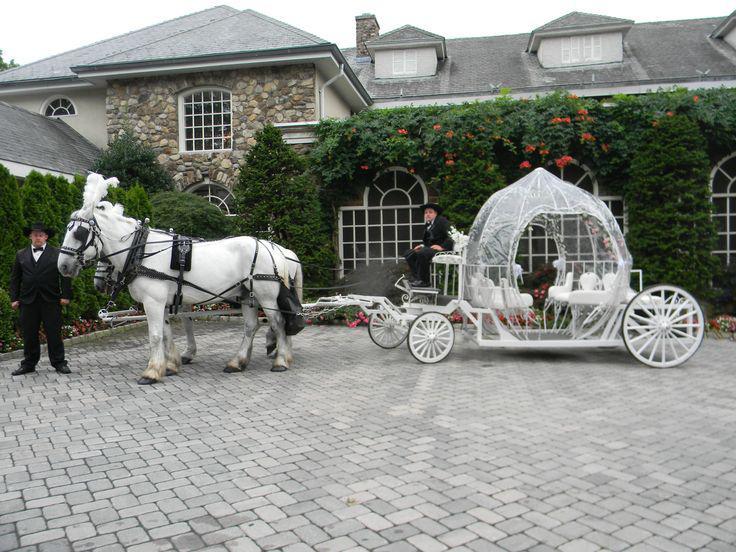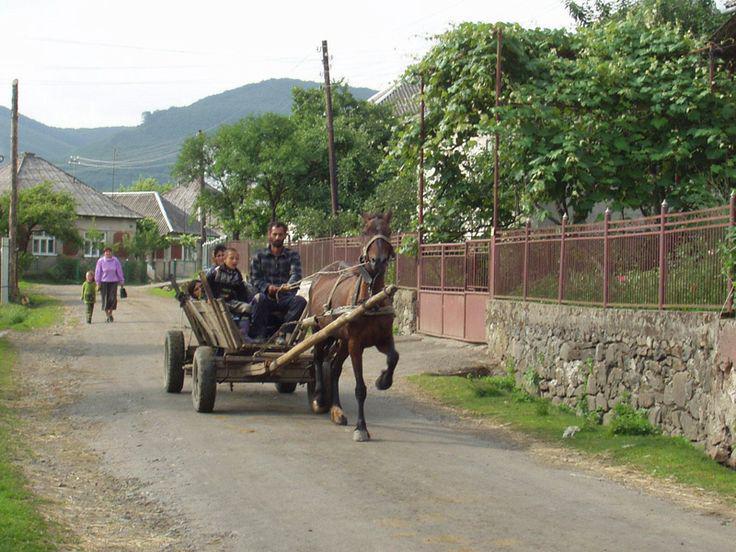The first image is the image on the left, the second image is the image on the right. Given the left and right images, does the statement "There is a white carriage led by a white horse in the left image." hold true? Answer yes or no. Yes. The first image is the image on the left, the second image is the image on the right. Examine the images to the left and right. Is the description "There are humans riding in a carriage in the right image." accurate? Answer yes or no. Yes. 